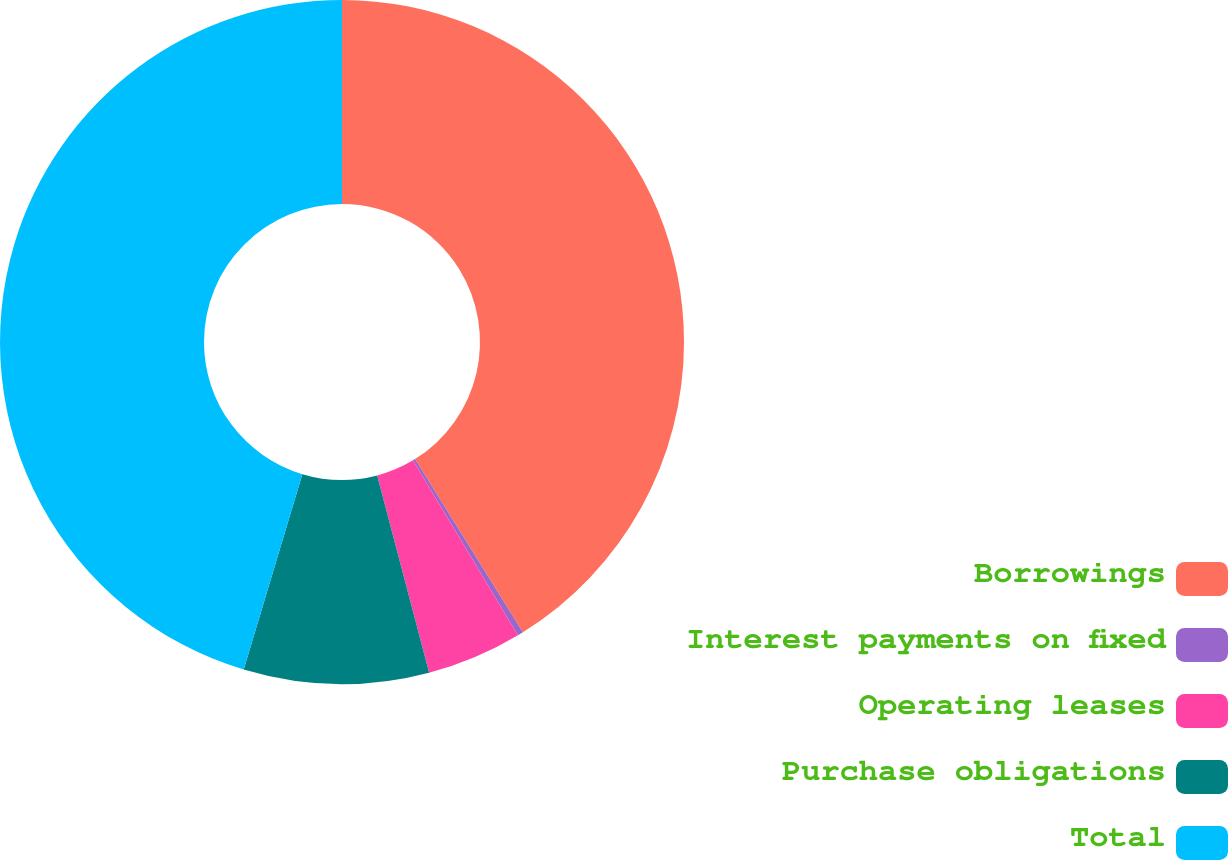<chart> <loc_0><loc_0><loc_500><loc_500><pie_chart><fcel>Borrowings<fcel>Interest payments on fixed<fcel>Operating leases<fcel>Purchase obligations<fcel>Total<nl><fcel>41.13%<fcel>0.27%<fcel>4.5%<fcel>8.74%<fcel>45.36%<nl></chart> 